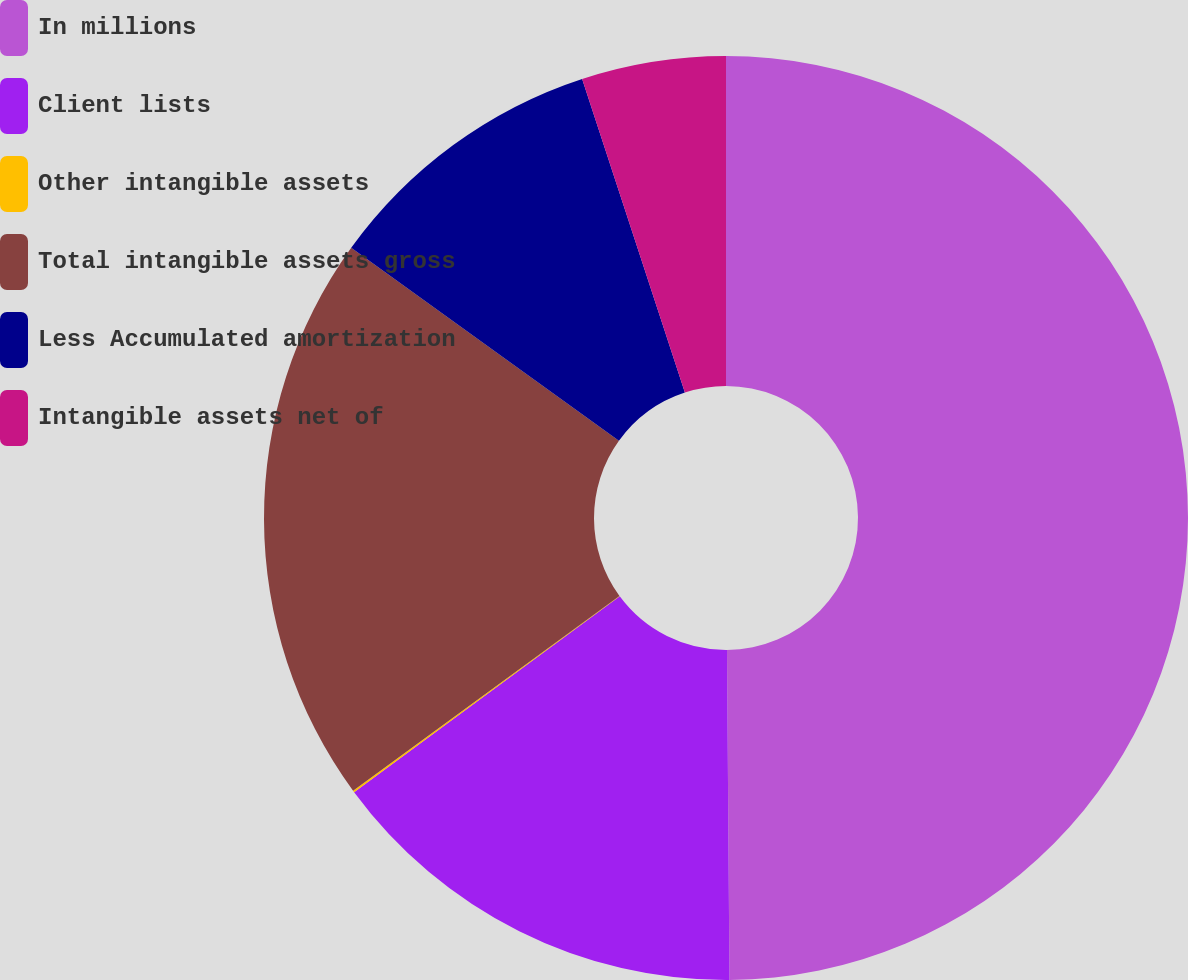Convert chart to OTSL. <chart><loc_0><loc_0><loc_500><loc_500><pie_chart><fcel>In millions<fcel>Client lists<fcel>Other intangible assets<fcel>Total intangible assets gross<fcel>Less Accumulated amortization<fcel>Intangible assets net of<nl><fcel>49.88%<fcel>15.01%<fcel>0.06%<fcel>19.99%<fcel>10.02%<fcel>5.04%<nl></chart> 